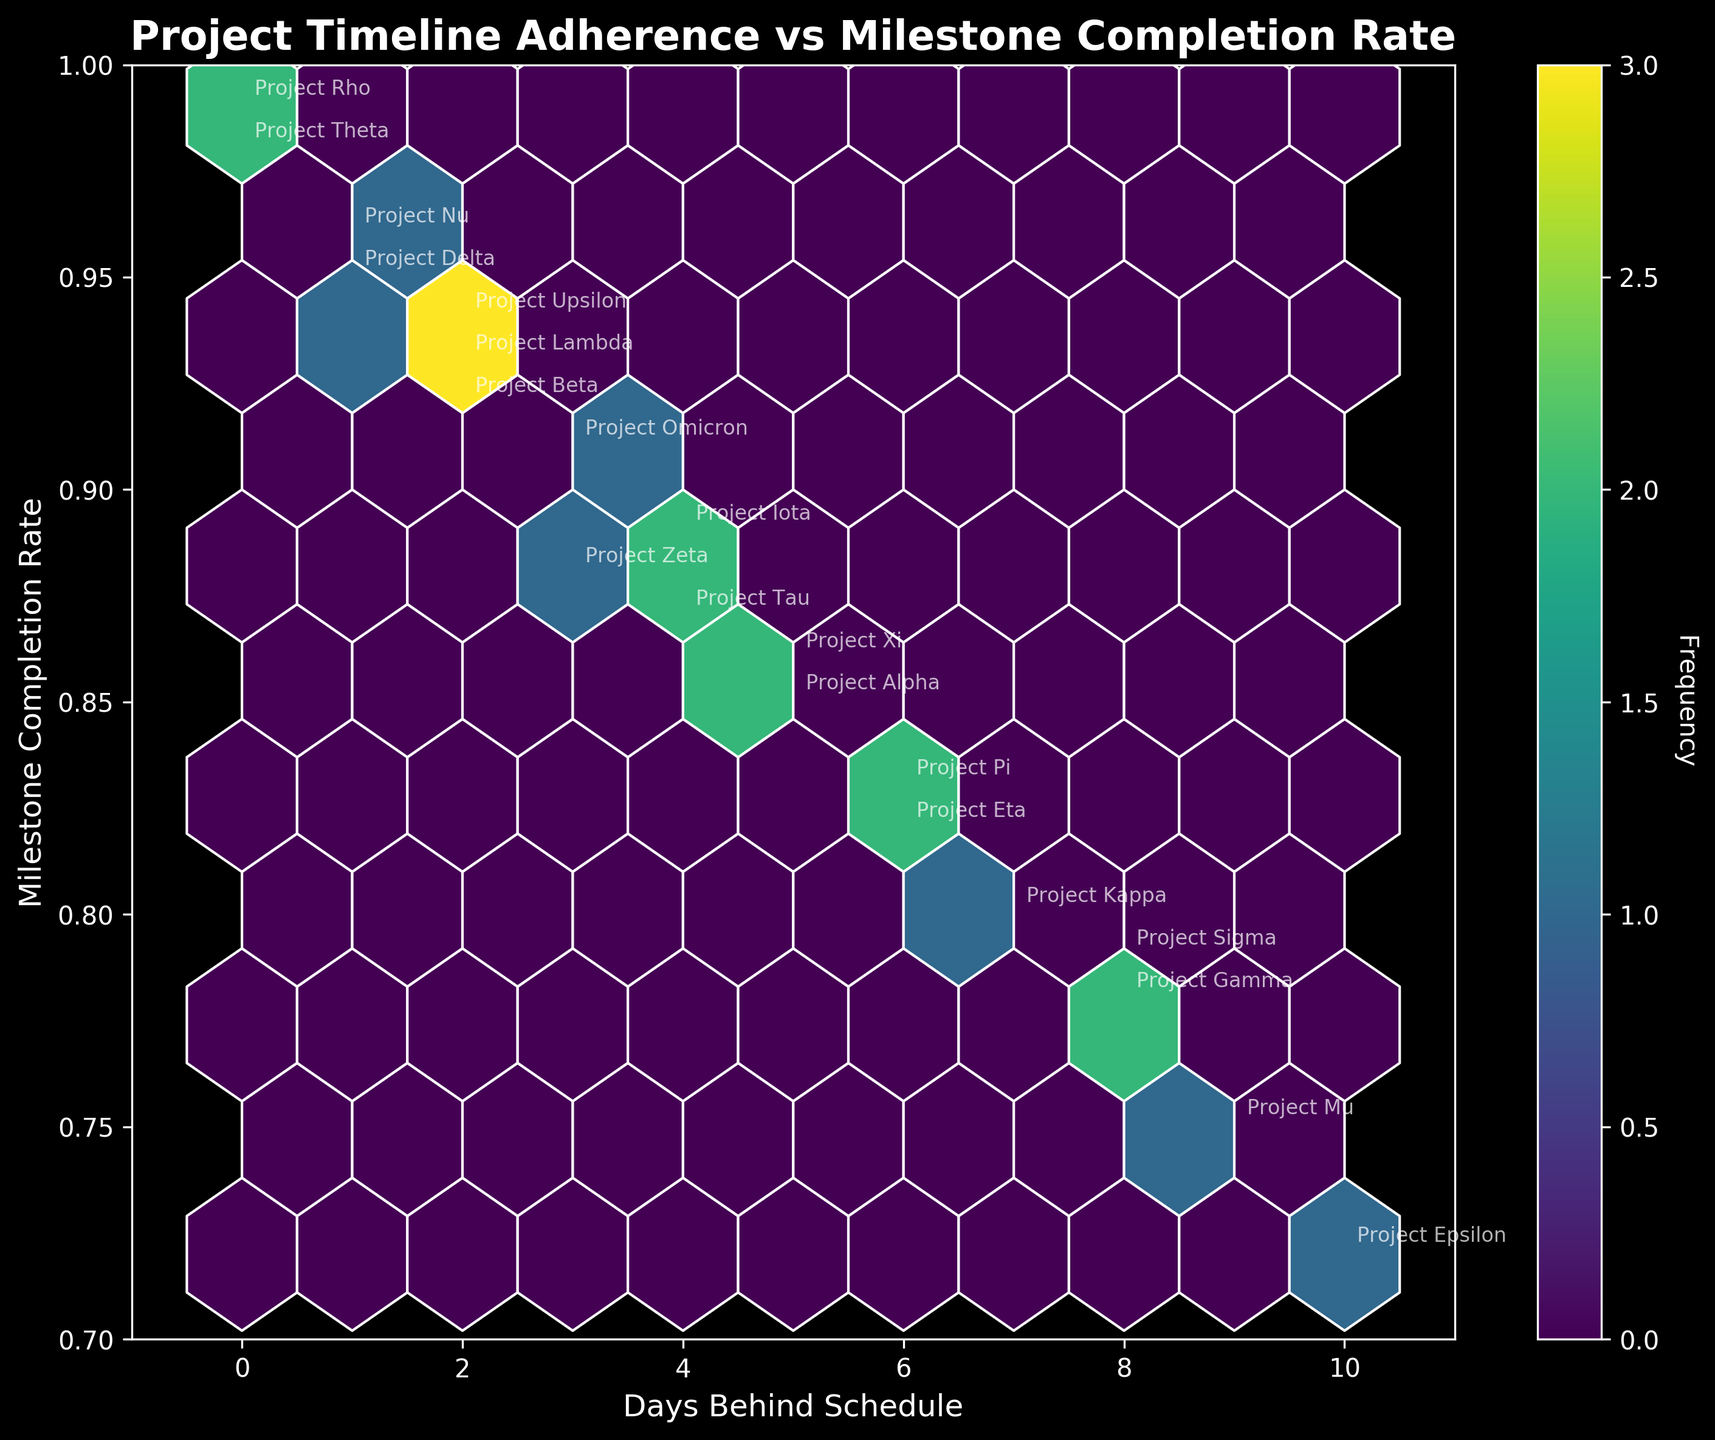What is the title of the plot? The title of the plot is shown at the top and it reads "Project Timeline Adherence vs Milestone Completion Rate".
Answer: Project Timeline Adherence vs Milestone Completion Rate How many projects have a milestone completion rate of 0.95 or higher? By looking at the y-axis and identifying the points at or above 0.95, we can count "Project Delta", "Project Nu", "Project Theta", and "Project Rho".
Answer: 4 Which project has the highest milestone completion rate, and how many days behind schedule is it? By identifying the highest point on the y-axis, we find "Project Rho" with a rate of 0.99 and 0 days behind schedule.
Answer: Project Rho, 0 days What is the color of the most densely populated hexagons? The color of the most densely populated hexagons can be observed as the darkest or most vibrant color in the plot's color gradient, which is a deeper shade of the viridis colormap, likely a dark green or blue.
Answer: Dark Green/Blue What is the range of days behind schedule for projects with completion rates below 0.8? By observing the figure, projects "Project Gamma", "Project Epsilon", "Project Mu", "Project Sigma", and "Project Kappa" have completion rates below 0.8 and their days behind schedule range from 7 to 10.
Answer: 7 to 10 Which project(s) show zero days behind schedule and what are their respective milestone completion rates? By identifying points on the x-axis at 0 days behind schedule, "Project Theta" has a rate of 0.98 and "Project Rho" has a rate of 0.99.
Answer: Project Theta (0.98), Project Rho (0.99) Between "Project Alpha" and "Project Xi", which one has a higher milestone completion rate and by how much? By locating the points for "Project Alpha" and "Project Xi" we see that "Project Alpha" has a rate of 0.85 and "Project Xi" has a rate of 0.86. The difference is 0.86 - 0.85 = 0.01.
Answer: Project Xi, 0.01 On average, how many days behind schedule are projects with a milestone completion rate greater than or equal to 0.95? Projects with completion rates of 0.95 or higher are "Project Delta", "Project Nu", "Project Theta", and "Project Rho". Their respective days behind schedule are 1, 1, 0, and 0. The average is (1 + 1 + 0 + 0) / 4 = 0.5 days.
Answer: 0.5 days What is the frequency of the most densely populated hexagon in this plot? By looking at the colorbar, the most densely populated hexagon indicates the highest frequency count, which can be directly read off the color gradient in the plot. Let's assume the highest frequency is indicated by a number like 3 (as an example from typical hexbin plots).
Answer: 3 Which projects are more than 5 days behind schedule and have milestone completion rates above 0.8? By identifying points with x-values greater than 5 and y-values above 0.8, "Project Pi" and "Project Eta" meet the criteria.
Answer: Project Pi, Project Eta 